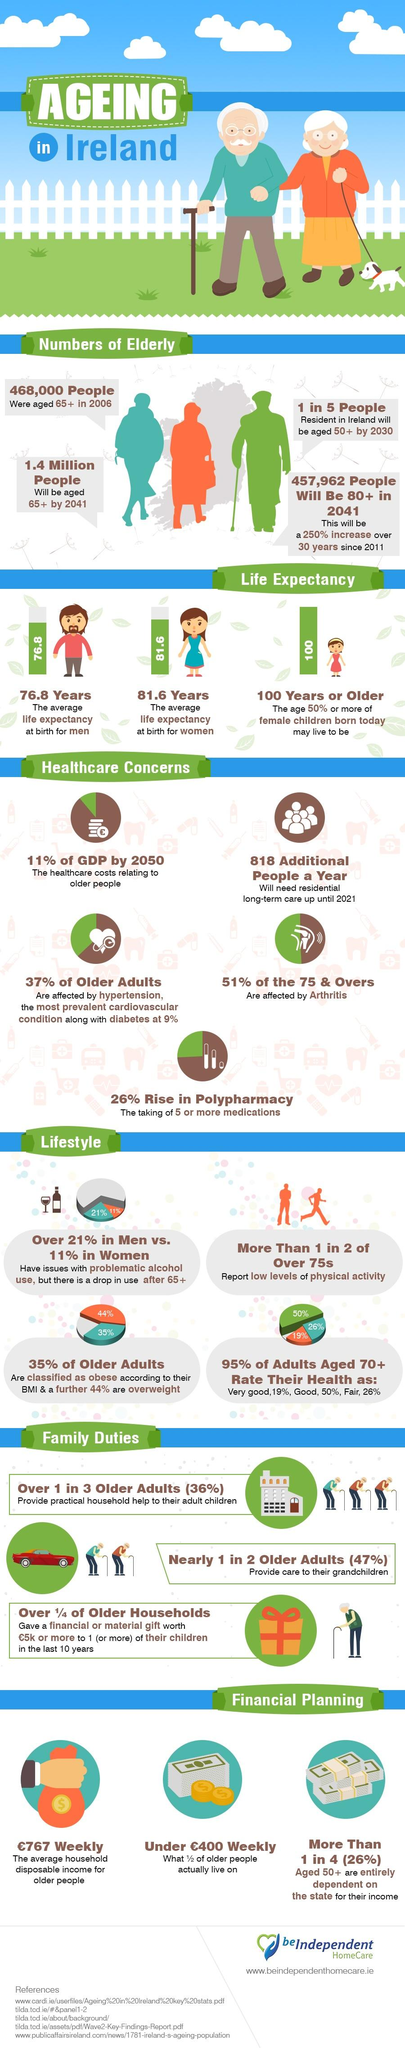Draw attention to some important aspects in this diagram. The average life expectancy at birth for women in Ireland is 81.6 years. According to recent data, only 21% of older adults in Ireland fall into neither the obese nor overweight category. By 2050, it is projected that healthcare costs relating to older people in Ireland will contribute approximately 11% of the country's GDP. The average household disposable income for older people in Ireland is approximately £767 per week. The average life expectancy at birth for men in Ireland is 76.8 years. 